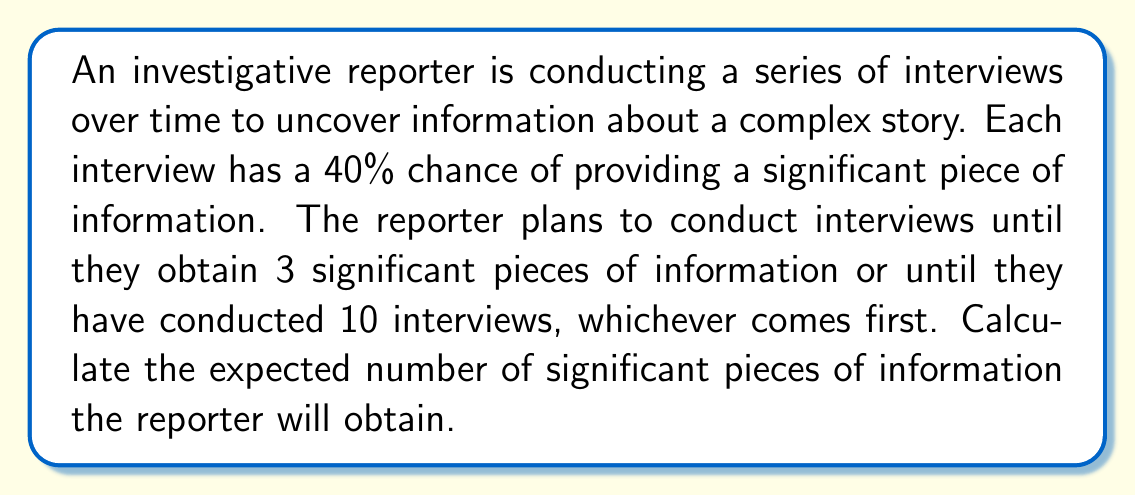What is the answer to this math problem? Let's approach this step-by-step:

1) First, we need to calculate the probability of getting exactly 0, 1, 2, or 3 significant pieces of information in 10 interviews.

2) This follows a binomial distribution, but we need to account for stopping after 3 successes. Let's define:
   $p = 0.4$ (probability of success in each interview)
   $q = 1 - p = 0.6$ (probability of failure in each interview)

3) Probability of exactly 0 successes in 10 interviews:
   $P(X=0) = q^{10} = 0.6^{10} \approx 0.0060$

4) Probability of exactly 1 success in 10 interviews:
   $P(X=1) = \binom{10}{1} p q^9 \approx 0.0403$

5) Probability of exactly 2 successes in 10 interviews:
   $P(X=2) = \binom{10}{2} p^2 q^8 \approx 0.1209$

6) Probability of 3 or more successes (we stop at 3):
   $P(X\geq3) = 1 - P(X=0) - P(X=1) - P(X=2) \approx 0.8328$

7) Now, we can calculate the expected value:
   $E(X) = 0 \cdot P(X=0) + 1 \cdot P(X=1) + 2 \cdot P(X=2) + 3 \cdot P(X\geq3)$

8) Substituting the values:
   $E(X) = 0 \cdot 0.0060 + 1 \cdot 0.0403 + 2 \cdot 0.1209 + 3 \cdot 0.8328$

9) Calculating:
   $E(X) = 0 + 0.0403 + 0.2418 + 2.4984 = 2.7805$

Therefore, the expected number of significant pieces of information is approximately 2.7805.
Answer: 2.7805 